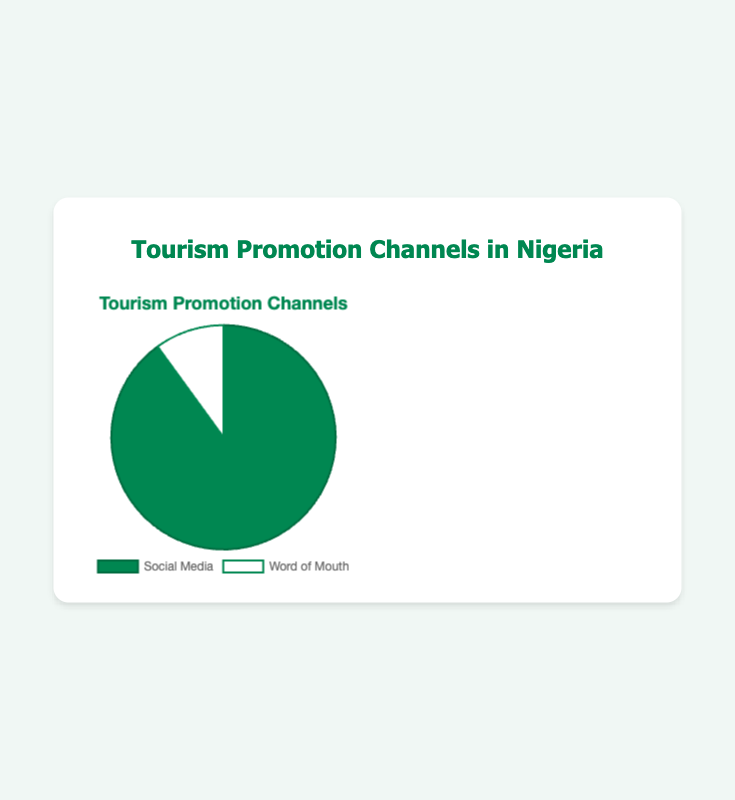What proportion of the total percentage does Social Media account for? Social Media accounts for 90% of the total percentage as the data shows Social Media with 90 and Word of Mouth with 10 out of 100.
Answer: 90% What is the total percentage attributed to Word of Mouth? The total percentage attributed to Word of Mouth is 10%, as can be seen in the data summary where Social Media is 90% and Word of Mouth is 10%.
Answer: 10% Which promotion channel has the higher percentage? By comparing the two data points, Social Media (90%) has a higher percentage than Word of Mouth (10%).
Answer: Social Media How much greater is the percentage of Social Media compared to Word of Mouth? The percentage of Social Media (90%) is 80% greater than Word of Mouth (10%). The difference is calculated as 90% - 10% = 80%.
Answer: 80% What are the components of Social Media and their respective percentages? The components of Social Media and their percentages are: Instagram (35%), Facebook (25%), Twitter (15%), YouTube (10%), and TikTok (5%). This is clearly laid out in the data under the 'Entities' section for Social Media.
Answer: Instagram (35%), Facebook (25%), Twitter (15%), YouTube (10%), TikTok (5%) Which platform has the highest percentage within the Social Media channel? Within the Social Media channel, Instagram has the highest percentage at 35%. This can be noted from the breakdown of Social Media components.
Answer: Instagram (35%) How do the percentages of Facebook and YouTube compare? Comparing the percentages, Facebook (25%) has a higher percentage than YouTube (10%). The data shows Facebook with 25% and YouTube with 10%.
Answer: Facebook (25%) If you sum the percentages of Instagram and Twitter, what total do you get? Summing the percentages of Instagram (35%) and Twitter (15%) gives a total of 50%. The calculations are: 35% + 15% = 50%.
Answer: 50% What percentage is dedicated to Family & Friends within Word of Mouth? Family & Friends holds a percentage of 70% within Word of Mouth, as indicated under the 'Entities' for the Word of Mouth channel.
Answer: 70% Compare the combined percentages of Facebook and Twitter with that of Family & Friends. The combined percentage of Facebook (25%) and Twitter (15%) is 40%, which is lower than that of Family & Friends, which is 70%. Calculations: 25% + 15% = 40%.
Answer: Family & Friends (70%) 